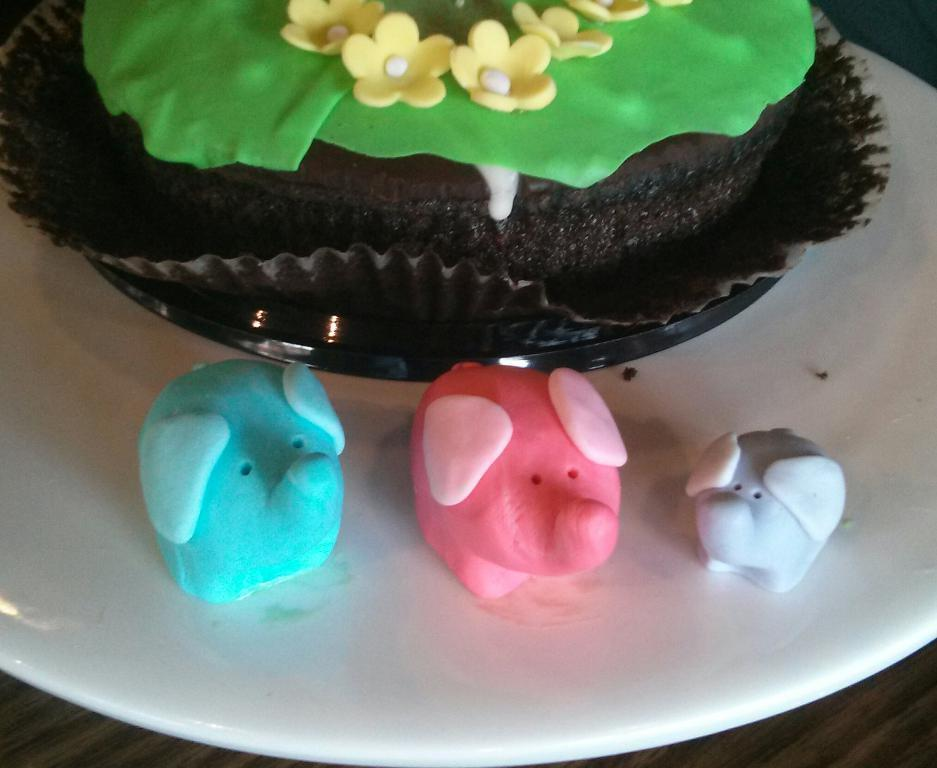What is located at the bottom of the image? There is a table at the bottom of the image. What is placed on the table? There is a plate on the table. What is on the plate? There is food on the plate. How does the table support the island in the image? There is no island present in the image, and the table is not supporting any island. 